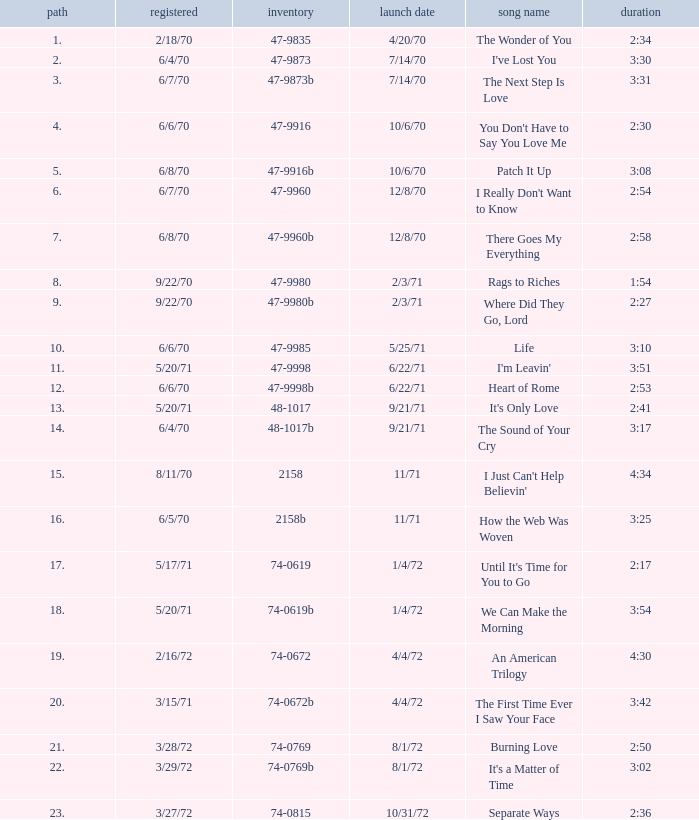Would you be able to parse every entry in this table? {'header': ['path', 'registered', 'inventory', 'launch date', 'song name', 'duration'], 'rows': [['1.', '2/18/70', '47-9835', '4/20/70', 'The Wonder of You', '2:34'], ['2.', '6/4/70', '47-9873', '7/14/70', "I've Lost You", '3:30'], ['3.', '6/7/70', '47-9873b', '7/14/70', 'The Next Step Is Love', '3:31'], ['4.', '6/6/70', '47-9916', '10/6/70', "You Don't Have to Say You Love Me", '2:30'], ['5.', '6/8/70', '47-9916b', '10/6/70', 'Patch It Up', '3:08'], ['6.', '6/7/70', '47-9960', '12/8/70', "I Really Don't Want to Know", '2:54'], ['7.', '6/8/70', '47-9960b', '12/8/70', 'There Goes My Everything', '2:58'], ['8.', '9/22/70', '47-9980', '2/3/71', 'Rags to Riches', '1:54'], ['9.', '9/22/70', '47-9980b', '2/3/71', 'Where Did They Go, Lord', '2:27'], ['10.', '6/6/70', '47-9985', '5/25/71', 'Life', '3:10'], ['11.', '5/20/71', '47-9998', '6/22/71', "I'm Leavin'", '3:51'], ['12.', '6/6/70', '47-9998b', '6/22/71', 'Heart of Rome', '2:53'], ['13.', '5/20/71', '48-1017', '9/21/71', "It's Only Love", '2:41'], ['14.', '6/4/70', '48-1017b', '9/21/71', 'The Sound of Your Cry', '3:17'], ['15.', '8/11/70', '2158', '11/71', "I Just Can't Help Believin'", '4:34'], ['16.', '6/5/70', '2158b', '11/71', 'How the Web Was Woven', '3:25'], ['17.', '5/17/71', '74-0619', '1/4/72', "Until It's Time for You to Go", '2:17'], ['18.', '5/20/71', '74-0619b', '1/4/72', 'We Can Make the Morning', '3:54'], ['19.', '2/16/72', '74-0672', '4/4/72', 'An American Trilogy', '4:30'], ['20.', '3/15/71', '74-0672b', '4/4/72', 'The First Time Ever I Saw Your Face', '3:42'], ['21.', '3/28/72', '74-0769', '8/1/72', 'Burning Love', '2:50'], ['22.', '3/29/72', '74-0769b', '8/1/72', "It's a Matter of Time", '3:02'], ['23.', '3/27/72', '74-0815', '10/31/72', 'Separate Ways', '2:36']]} What is the highest track for Burning Love? 21.0. 